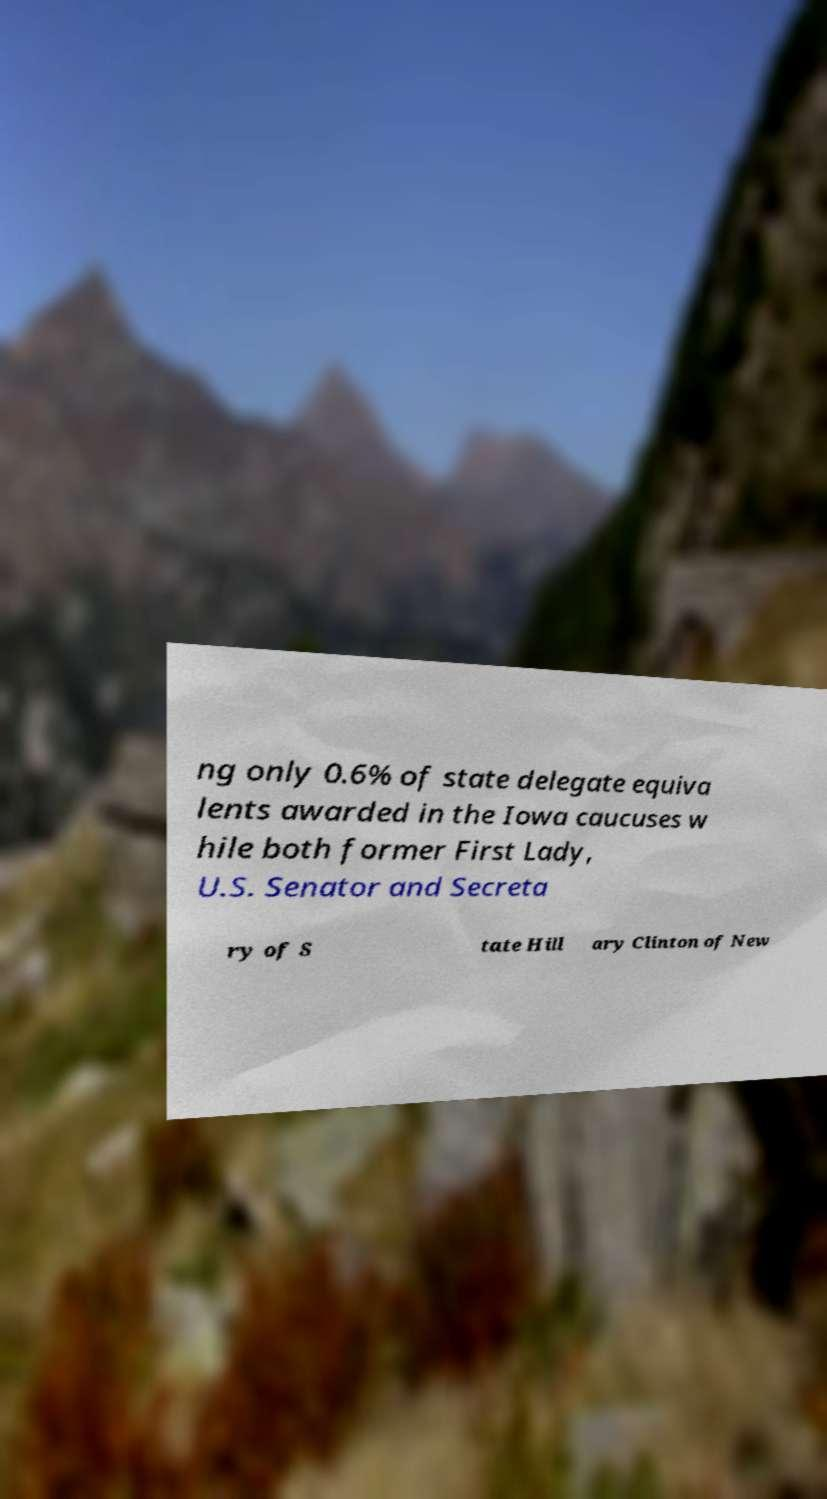Please read and relay the text visible in this image. What does it say? ng only 0.6% of state delegate equiva lents awarded in the Iowa caucuses w hile both former First Lady, U.S. Senator and Secreta ry of S tate Hill ary Clinton of New 